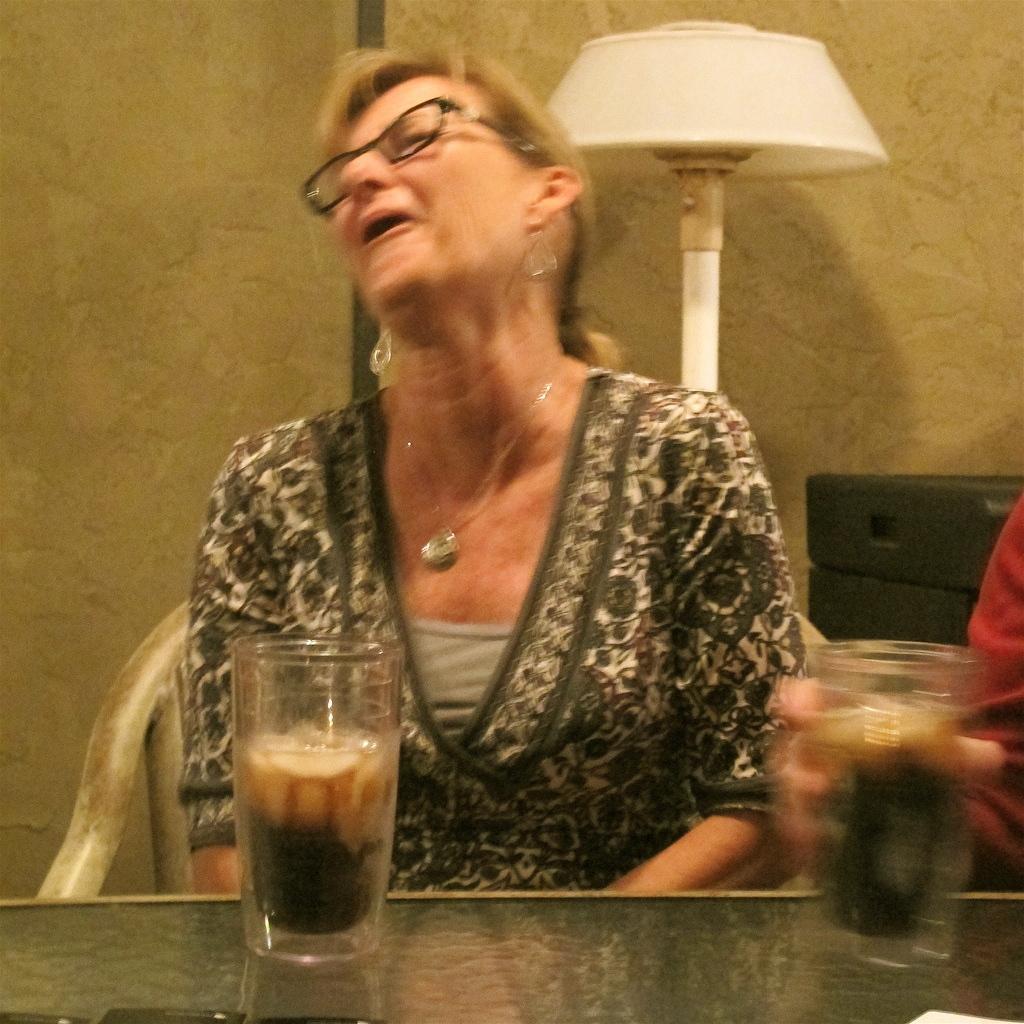Can you describe this image briefly? In this image there is a person sitting on the chair. In front of her there is a table. On top of the table there are glasses. Beside her there is another person. Behind her there is a lamp. There is a wall. In front of the wall there is a black color object. 